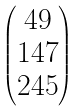Convert formula to latex. <formula><loc_0><loc_0><loc_500><loc_500>\begin{pmatrix} 4 9 \\ 1 4 7 \\ 2 4 5 \end{pmatrix}</formula> 